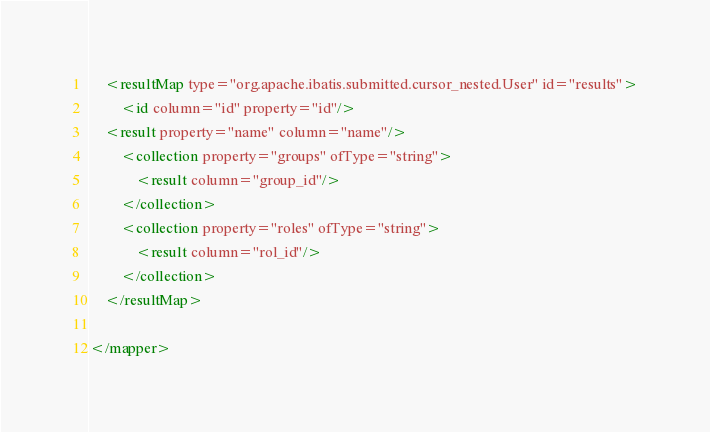Convert code to text. <code><loc_0><loc_0><loc_500><loc_500><_XML_>
	<resultMap type="org.apache.ibatis.submitted.cursor_nested.User" id="results">
		<id column="id" property="id"/>
    <result property="name" column="name"/>
		<collection property="groups" ofType="string">
			<result column="group_id"/>
		</collection>
		<collection property="roles" ofType="string">
			<result column="rol_id"/>
		</collection>
	</resultMap>

</mapper>
</code> 